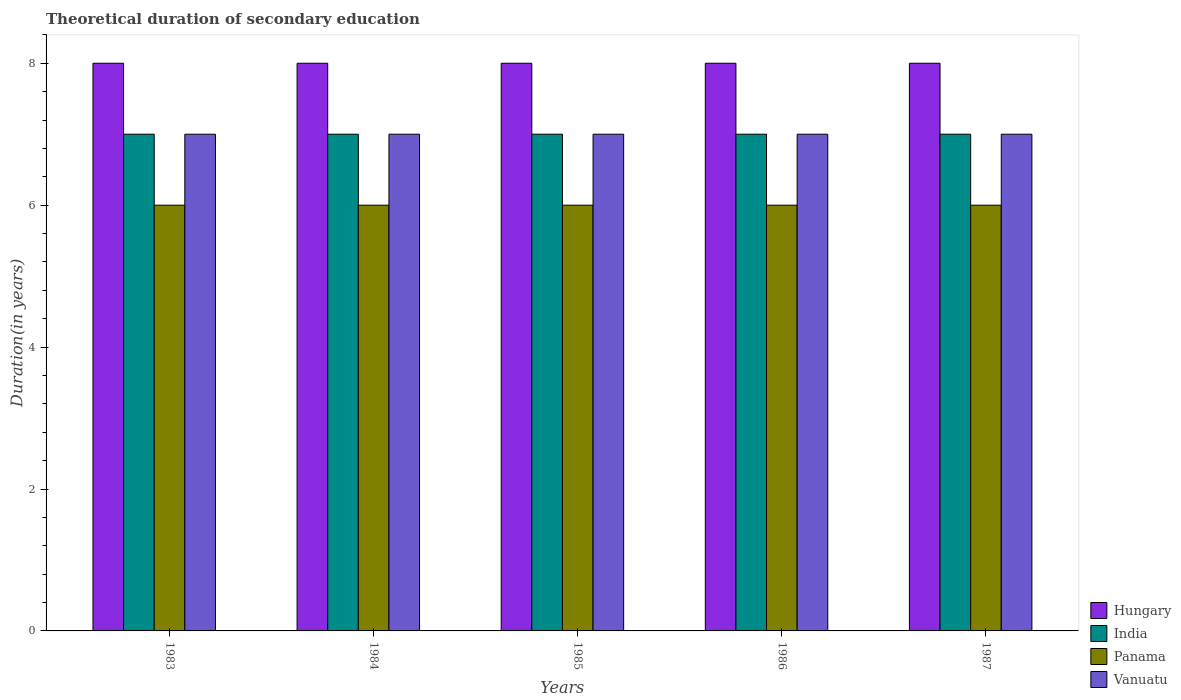How many groups of bars are there?
Give a very brief answer. 5. Are the number of bars on each tick of the X-axis equal?
Your response must be concise. Yes. What is the label of the 3rd group of bars from the left?
Your answer should be compact. 1985. In how many cases, is the number of bars for a given year not equal to the number of legend labels?
Ensure brevity in your answer.  0. What is the total theoretical duration of secondary education in India in 1987?
Make the answer very short. 7. Across all years, what is the maximum total theoretical duration of secondary education in India?
Keep it short and to the point. 7. Across all years, what is the minimum total theoretical duration of secondary education in Vanuatu?
Offer a terse response. 7. In which year was the total theoretical duration of secondary education in Vanuatu maximum?
Give a very brief answer. 1983. What is the total total theoretical duration of secondary education in India in the graph?
Provide a succinct answer. 35. What is the difference between the total theoretical duration of secondary education in Vanuatu in 1984 and that in 1987?
Make the answer very short. 0. What is the difference between the total theoretical duration of secondary education in Hungary in 1987 and the total theoretical duration of secondary education in Panama in 1985?
Provide a short and direct response. 2. In the year 1986, what is the difference between the total theoretical duration of secondary education in Hungary and total theoretical duration of secondary education in Panama?
Your answer should be compact. 2. Is the total theoretical duration of secondary education in Hungary in 1984 less than that in 1986?
Offer a terse response. No. In how many years, is the total theoretical duration of secondary education in Vanuatu greater than the average total theoretical duration of secondary education in Vanuatu taken over all years?
Your response must be concise. 0. What does the 4th bar from the left in 1984 represents?
Ensure brevity in your answer.  Vanuatu. What does the 2nd bar from the right in 1987 represents?
Make the answer very short. Panama. Is it the case that in every year, the sum of the total theoretical duration of secondary education in Hungary and total theoretical duration of secondary education in Panama is greater than the total theoretical duration of secondary education in India?
Your response must be concise. Yes. How many bars are there?
Make the answer very short. 20. How many years are there in the graph?
Keep it short and to the point. 5. What is the difference between two consecutive major ticks on the Y-axis?
Your answer should be very brief. 2. What is the title of the graph?
Your response must be concise. Theoretical duration of secondary education. Does "Papua New Guinea" appear as one of the legend labels in the graph?
Your response must be concise. No. What is the label or title of the Y-axis?
Offer a very short reply. Duration(in years). What is the Duration(in years) in Hungary in 1983?
Offer a terse response. 8. What is the Duration(in years) of India in 1983?
Provide a succinct answer. 7. What is the Duration(in years) in Panama in 1983?
Offer a terse response. 6. What is the Duration(in years) in Vanuatu in 1983?
Ensure brevity in your answer.  7. What is the Duration(in years) of India in 1984?
Your response must be concise. 7. What is the Duration(in years) in Vanuatu in 1984?
Your response must be concise. 7. What is the Duration(in years) in Hungary in 1985?
Offer a terse response. 8. What is the Duration(in years) in India in 1985?
Provide a succinct answer. 7. What is the Duration(in years) in Panama in 1985?
Ensure brevity in your answer.  6. What is the Duration(in years) of Vanuatu in 1985?
Offer a very short reply. 7. What is the Duration(in years) in Hungary in 1986?
Your answer should be very brief. 8. What is the Duration(in years) of Panama in 1987?
Keep it short and to the point. 6. Across all years, what is the maximum Duration(in years) in India?
Your response must be concise. 7. Across all years, what is the maximum Duration(in years) in Panama?
Your answer should be very brief. 6. Across all years, what is the minimum Duration(in years) of India?
Offer a terse response. 7. Across all years, what is the minimum Duration(in years) in Panama?
Provide a short and direct response. 6. What is the total Duration(in years) in Hungary in the graph?
Your response must be concise. 40. What is the difference between the Duration(in years) in Hungary in 1983 and that in 1984?
Provide a succinct answer. 0. What is the difference between the Duration(in years) of Panama in 1983 and that in 1985?
Provide a short and direct response. 0. What is the difference between the Duration(in years) of Hungary in 1983 and that in 1986?
Provide a succinct answer. 0. What is the difference between the Duration(in years) of India in 1983 and that in 1986?
Make the answer very short. 0. What is the difference between the Duration(in years) in Vanuatu in 1983 and that in 1986?
Your answer should be compact. 0. What is the difference between the Duration(in years) in Hungary in 1983 and that in 1987?
Ensure brevity in your answer.  0. What is the difference between the Duration(in years) in India in 1983 and that in 1987?
Your answer should be very brief. 0. What is the difference between the Duration(in years) of Panama in 1983 and that in 1987?
Offer a terse response. 0. What is the difference between the Duration(in years) of Panama in 1984 and that in 1985?
Offer a terse response. 0. What is the difference between the Duration(in years) in Hungary in 1984 and that in 1986?
Ensure brevity in your answer.  0. What is the difference between the Duration(in years) in India in 1984 and that in 1986?
Make the answer very short. 0. What is the difference between the Duration(in years) in Panama in 1984 and that in 1986?
Provide a short and direct response. 0. What is the difference between the Duration(in years) of Hungary in 1984 and that in 1987?
Ensure brevity in your answer.  0. What is the difference between the Duration(in years) of India in 1984 and that in 1987?
Keep it short and to the point. 0. What is the difference between the Duration(in years) in Vanuatu in 1984 and that in 1987?
Your answer should be very brief. 0. What is the difference between the Duration(in years) in Hungary in 1985 and that in 1986?
Give a very brief answer. 0. What is the difference between the Duration(in years) in Panama in 1985 and that in 1986?
Give a very brief answer. 0. What is the difference between the Duration(in years) in Vanuatu in 1985 and that in 1986?
Your response must be concise. 0. What is the difference between the Duration(in years) of Hungary in 1985 and that in 1987?
Keep it short and to the point. 0. What is the difference between the Duration(in years) of India in 1985 and that in 1987?
Offer a very short reply. 0. What is the difference between the Duration(in years) in Vanuatu in 1985 and that in 1987?
Ensure brevity in your answer.  0. What is the difference between the Duration(in years) in Hungary in 1986 and that in 1987?
Offer a very short reply. 0. What is the difference between the Duration(in years) in Vanuatu in 1986 and that in 1987?
Provide a short and direct response. 0. What is the difference between the Duration(in years) of Hungary in 1983 and the Duration(in years) of India in 1984?
Your response must be concise. 1. What is the difference between the Duration(in years) in Hungary in 1983 and the Duration(in years) in Panama in 1985?
Your answer should be very brief. 2. What is the difference between the Duration(in years) of India in 1983 and the Duration(in years) of Vanuatu in 1985?
Your response must be concise. 0. What is the difference between the Duration(in years) of Hungary in 1983 and the Duration(in years) of Panama in 1986?
Provide a short and direct response. 2. What is the difference between the Duration(in years) in India in 1983 and the Duration(in years) in Panama in 1986?
Give a very brief answer. 1. What is the difference between the Duration(in years) of India in 1983 and the Duration(in years) of Vanuatu in 1986?
Your response must be concise. 0. What is the difference between the Duration(in years) in Hungary in 1983 and the Duration(in years) in India in 1987?
Provide a succinct answer. 1. What is the difference between the Duration(in years) of Hungary in 1983 and the Duration(in years) of Panama in 1987?
Provide a succinct answer. 2. What is the difference between the Duration(in years) of Hungary in 1983 and the Duration(in years) of Vanuatu in 1987?
Offer a very short reply. 1. What is the difference between the Duration(in years) in India in 1983 and the Duration(in years) in Panama in 1987?
Your answer should be compact. 1. What is the difference between the Duration(in years) in Panama in 1983 and the Duration(in years) in Vanuatu in 1987?
Give a very brief answer. -1. What is the difference between the Duration(in years) of Hungary in 1984 and the Duration(in years) of Panama in 1985?
Your answer should be very brief. 2. What is the difference between the Duration(in years) in Hungary in 1984 and the Duration(in years) in Vanuatu in 1985?
Provide a short and direct response. 1. What is the difference between the Duration(in years) in Hungary in 1984 and the Duration(in years) in Panama in 1986?
Make the answer very short. 2. What is the difference between the Duration(in years) in Hungary in 1984 and the Duration(in years) in Vanuatu in 1986?
Keep it short and to the point. 1. What is the difference between the Duration(in years) in India in 1984 and the Duration(in years) in Panama in 1986?
Your answer should be very brief. 1. What is the difference between the Duration(in years) in Hungary in 1984 and the Duration(in years) in Vanuatu in 1987?
Your response must be concise. 1. What is the difference between the Duration(in years) of India in 1984 and the Duration(in years) of Panama in 1987?
Provide a short and direct response. 1. What is the difference between the Duration(in years) of India in 1984 and the Duration(in years) of Vanuatu in 1987?
Your answer should be compact. 0. What is the difference between the Duration(in years) in Hungary in 1985 and the Duration(in years) in India in 1987?
Your response must be concise. 1. What is the difference between the Duration(in years) of Hungary in 1985 and the Duration(in years) of Panama in 1987?
Make the answer very short. 2. What is the difference between the Duration(in years) of Hungary in 1985 and the Duration(in years) of Vanuatu in 1987?
Offer a terse response. 1. What is the difference between the Duration(in years) of India in 1985 and the Duration(in years) of Vanuatu in 1987?
Your answer should be compact. 0. What is the difference between the Duration(in years) of Hungary in 1986 and the Duration(in years) of India in 1987?
Your answer should be very brief. 1. What is the difference between the Duration(in years) of Hungary in 1986 and the Duration(in years) of Panama in 1987?
Ensure brevity in your answer.  2. What is the difference between the Duration(in years) in India in 1986 and the Duration(in years) in Panama in 1987?
Your response must be concise. 1. What is the difference between the Duration(in years) in Panama in 1986 and the Duration(in years) in Vanuatu in 1987?
Keep it short and to the point. -1. What is the average Duration(in years) of Hungary per year?
Keep it short and to the point. 8. What is the average Duration(in years) in India per year?
Make the answer very short. 7. What is the average Duration(in years) in Vanuatu per year?
Provide a succinct answer. 7. In the year 1983, what is the difference between the Duration(in years) of Hungary and Duration(in years) of India?
Provide a succinct answer. 1. In the year 1983, what is the difference between the Duration(in years) in Hungary and Duration(in years) in Vanuatu?
Keep it short and to the point. 1. In the year 1983, what is the difference between the Duration(in years) in India and Duration(in years) in Panama?
Your answer should be compact. 1. In the year 1984, what is the difference between the Duration(in years) in Hungary and Duration(in years) in Panama?
Provide a short and direct response. 2. In the year 1984, what is the difference between the Duration(in years) in Hungary and Duration(in years) in Vanuatu?
Ensure brevity in your answer.  1. In the year 1984, what is the difference between the Duration(in years) of India and Duration(in years) of Panama?
Give a very brief answer. 1. In the year 1985, what is the difference between the Duration(in years) in Hungary and Duration(in years) in India?
Provide a short and direct response. 1. In the year 1985, what is the difference between the Duration(in years) of India and Duration(in years) of Panama?
Provide a short and direct response. 1. In the year 1985, what is the difference between the Duration(in years) of India and Duration(in years) of Vanuatu?
Offer a very short reply. 0. In the year 1985, what is the difference between the Duration(in years) of Panama and Duration(in years) of Vanuatu?
Ensure brevity in your answer.  -1. In the year 1986, what is the difference between the Duration(in years) of Hungary and Duration(in years) of India?
Your answer should be compact. 1. In the year 1986, what is the difference between the Duration(in years) in Hungary and Duration(in years) in Panama?
Give a very brief answer. 2. In the year 1987, what is the difference between the Duration(in years) in Hungary and Duration(in years) in India?
Provide a short and direct response. 1. In the year 1987, what is the difference between the Duration(in years) in Hungary and Duration(in years) in Panama?
Give a very brief answer. 2. In the year 1987, what is the difference between the Duration(in years) of India and Duration(in years) of Panama?
Your response must be concise. 1. In the year 1987, what is the difference between the Duration(in years) in Panama and Duration(in years) in Vanuatu?
Your answer should be compact. -1. What is the ratio of the Duration(in years) in Panama in 1983 to that in 1984?
Give a very brief answer. 1. What is the ratio of the Duration(in years) in Panama in 1983 to that in 1985?
Offer a very short reply. 1. What is the ratio of the Duration(in years) in Vanuatu in 1983 to that in 1985?
Offer a terse response. 1. What is the ratio of the Duration(in years) of Hungary in 1983 to that in 1986?
Keep it short and to the point. 1. What is the ratio of the Duration(in years) of India in 1983 to that in 1986?
Offer a terse response. 1. What is the ratio of the Duration(in years) in Panama in 1983 to that in 1986?
Provide a succinct answer. 1. What is the ratio of the Duration(in years) of Vanuatu in 1983 to that in 1986?
Provide a short and direct response. 1. What is the ratio of the Duration(in years) in India in 1983 to that in 1987?
Offer a terse response. 1. What is the ratio of the Duration(in years) in Hungary in 1984 to that in 1985?
Provide a succinct answer. 1. What is the ratio of the Duration(in years) in Panama in 1984 to that in 1985?
Offer a very short reply. 1. What is the ratio of the Duration(in years) of Hungary in 1984 to that in 1986?
Your answer should be very brief. 1. What is the ratio of the Duration(in years) of Vanuatu in 1984 to that in 1986?
Offer a terse response. 1. What is the ratio of the Duration(in years) in Hungary in 1984 to that in 1987?
Your answer should be very brief. 1. What is the ratio of the Duration(in years) of India in 1984 to that in 1987?
Make the answer very short. 1. What is the ratio of the Duration(in years) in Panama in 1984 to that in 1987?
Your answer should be very brief. 1. What is the ratio of the Duration(in years) of Vanuatu in 1984 to that in 1987?
Provide a succinct answer. 1. What is the ratio of the Duration(in years) of Hungary in 1985 to that in 1986?
Ensure brevity in your answer.  1. What is the ratio of the Duration(in years) in India in 1985 to that in 1986?
Provide a short and direct response. 1. What is the ratio of the Duration(in years) in Panama in 1985 to that in 1986?
Ensure brevity in your answer.  1. What is the ratio of the Duration(in years) of Hungary in 1985 to that in 1987?
Give a very brief answer. 1. What is the ratio of the Duration(in years) in India in 1985 to that in 1987?
Provide a short and direct response. 1. What is the ratio of the Duration(in years) of Hungary in 1986 to that in 1987?
Your answer should be compact. 1. What is the difference between the highest and the second highest Duration(in years) of India?
Keep it short and to the point. 0. What is the difference between the highest and the second highest Duration(in years) in Vanuatu?
Make the answer very short. 0. What is the difference between the highest and the lowest Duration(in years) in India?
Ensure brevity in your answer.  0. What is the difference between the highest and the lowest Duration(in years) of Panama?
Offer a terse response. 0. What is the difference between the highest and the lowest Duration(in years) in Vanuatu?
Your answer should be compact. 0. 